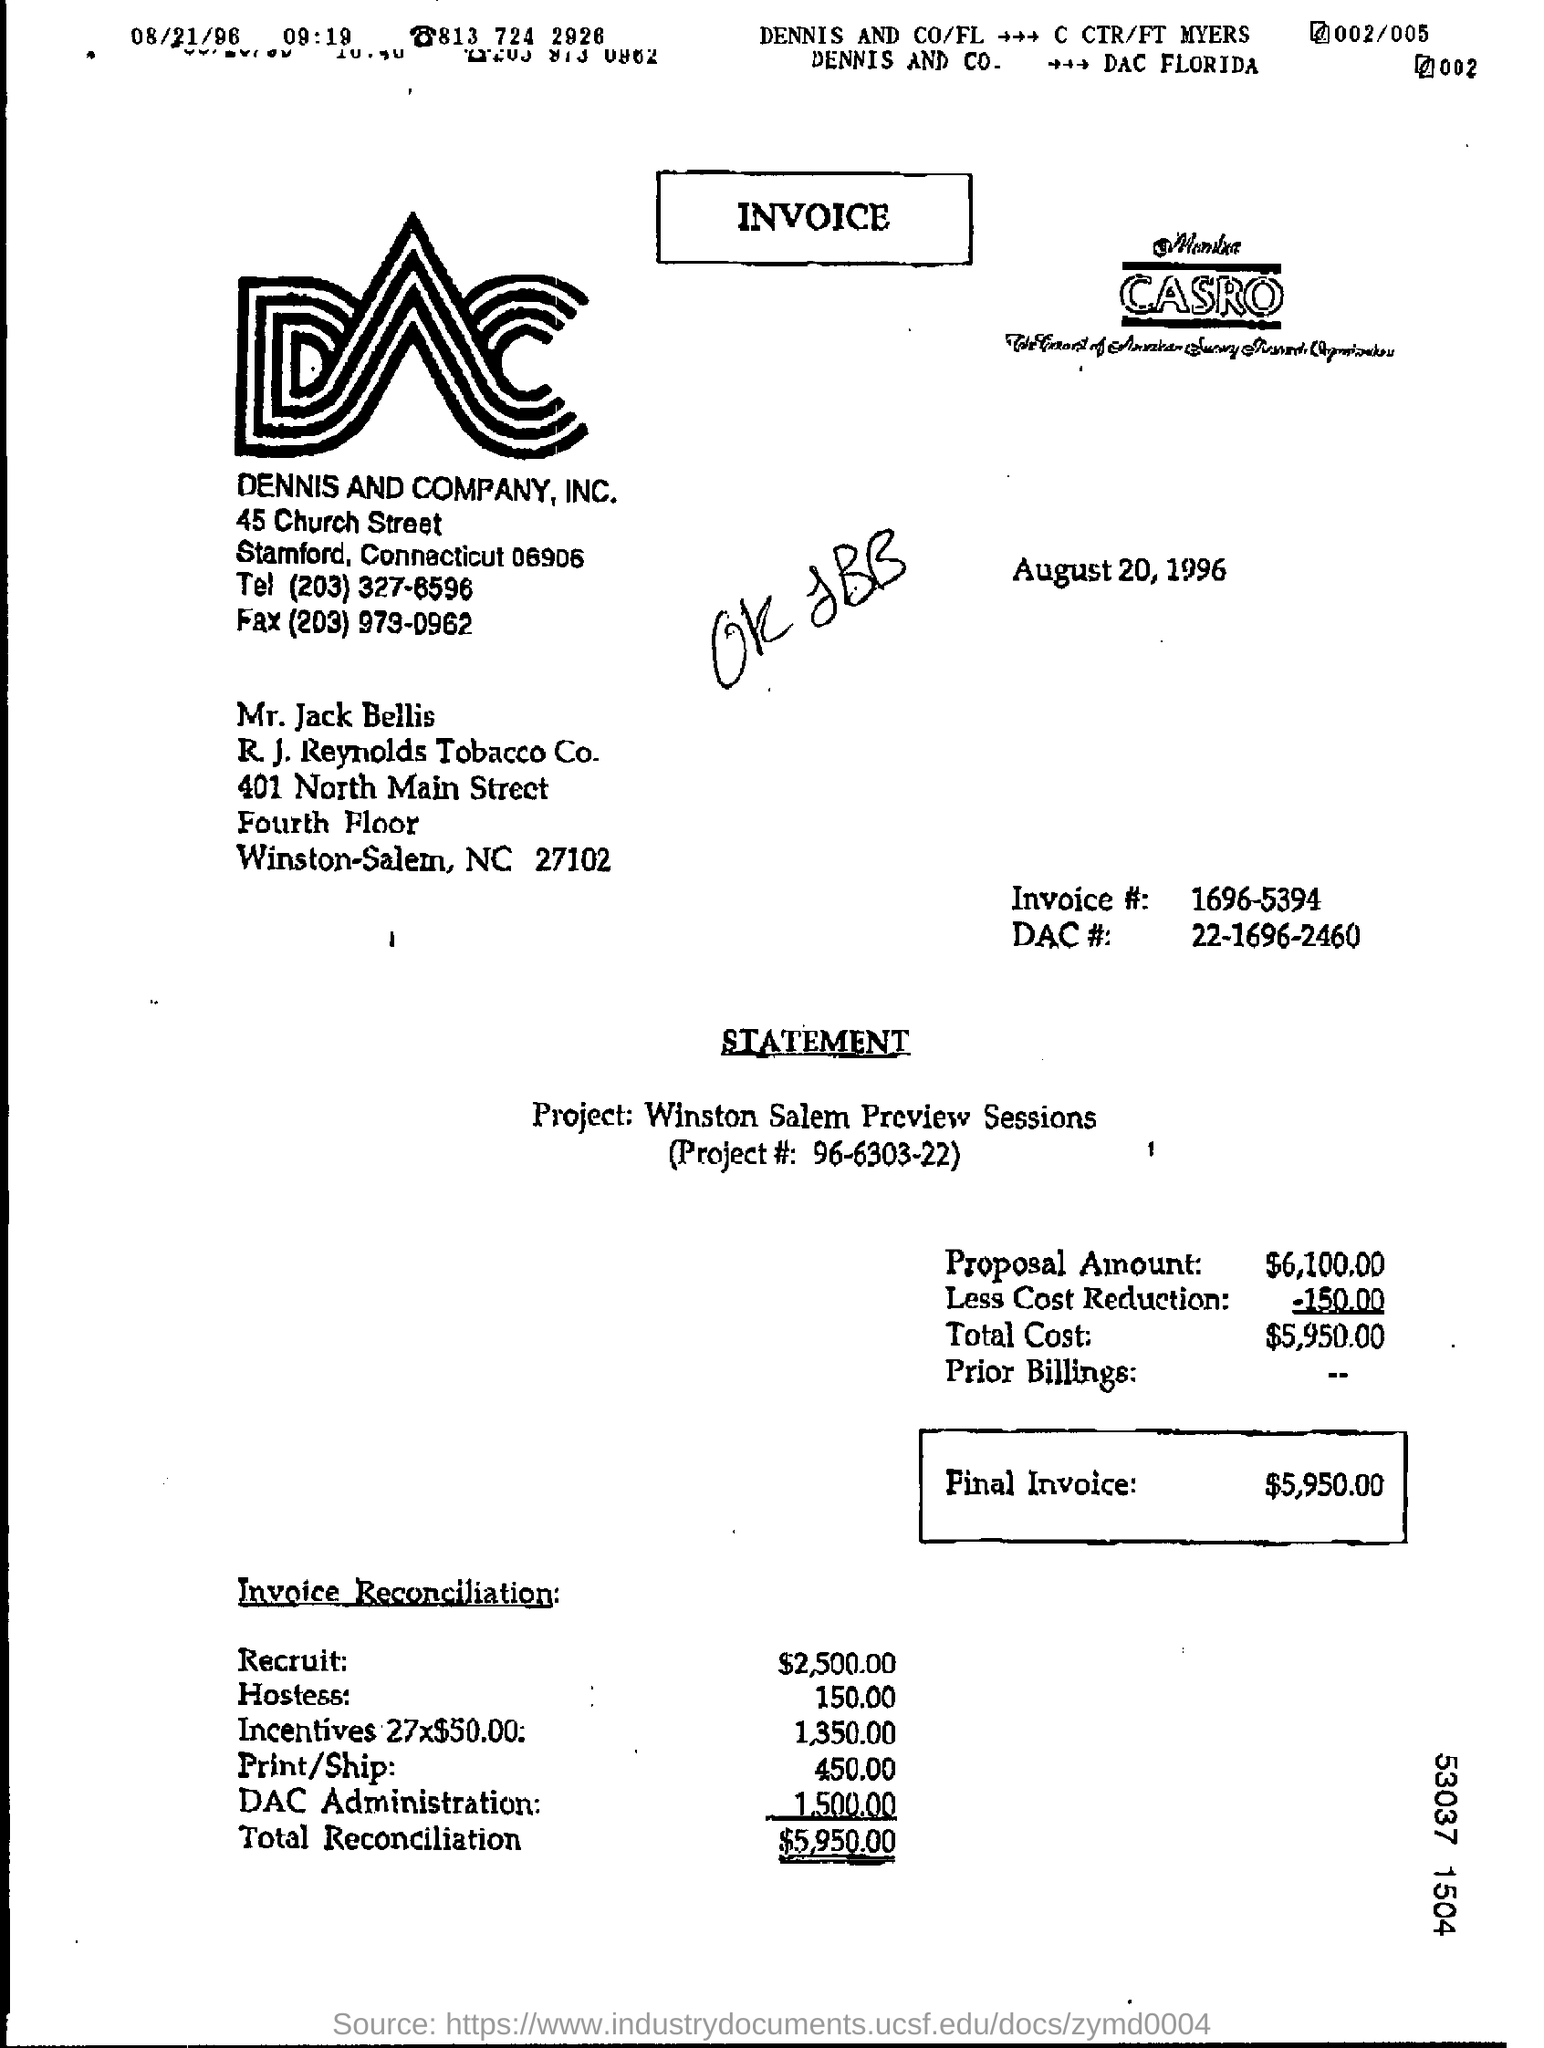What is the heading of the document?
Your answer should be very brief. Invoice. What is the Proposal Amount?
Provide a succinct answer. $6,100.00. What is the Total Reconciliation?
Offer a terse response. $5,950.00. Which project is this invoice related to?
Ensure brevity in your answer.  Winston Salem Preview Sessions. What is the invoice #?
Give a very brief answer. 1696-5394. What is the project#?
Provide a short and direct response. 96-6303-22. 